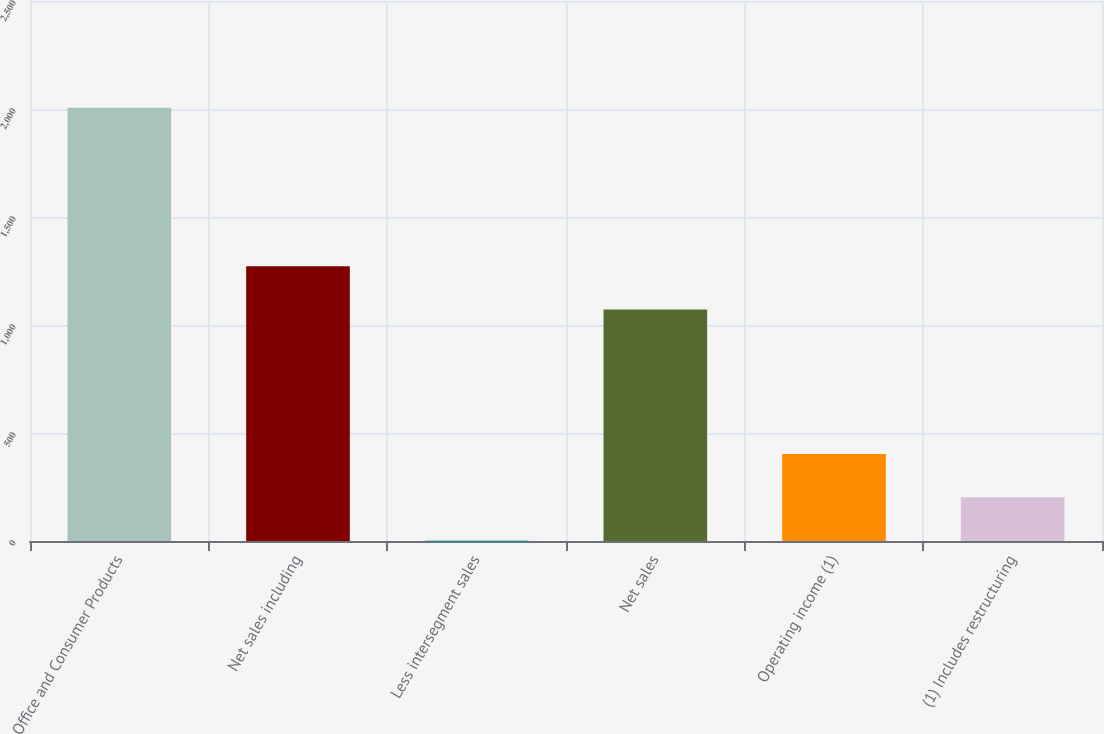Convert chart to OTSL. <chart><loc_0><loc_0><loc_500><loc_500><bar_chart><fcel>Office and Consumer Products<fcel>Net sales including<fcel>Less intersegment sales<fcel>Net sales<fcel>Operating income (1)<fcel>(1) Includes restructuring<nl><fcel>2006<fcel>1272.42<fcel>1.8<fcel>1072<fcel>402.64<fcel>202.22<nl></chart> 